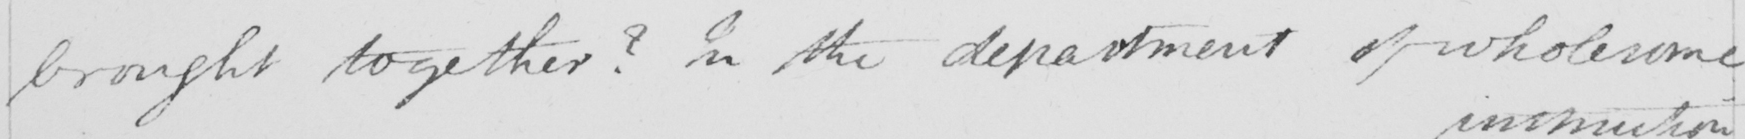What text is written in this handwritten line? brought together ?  In the department of wholesome 